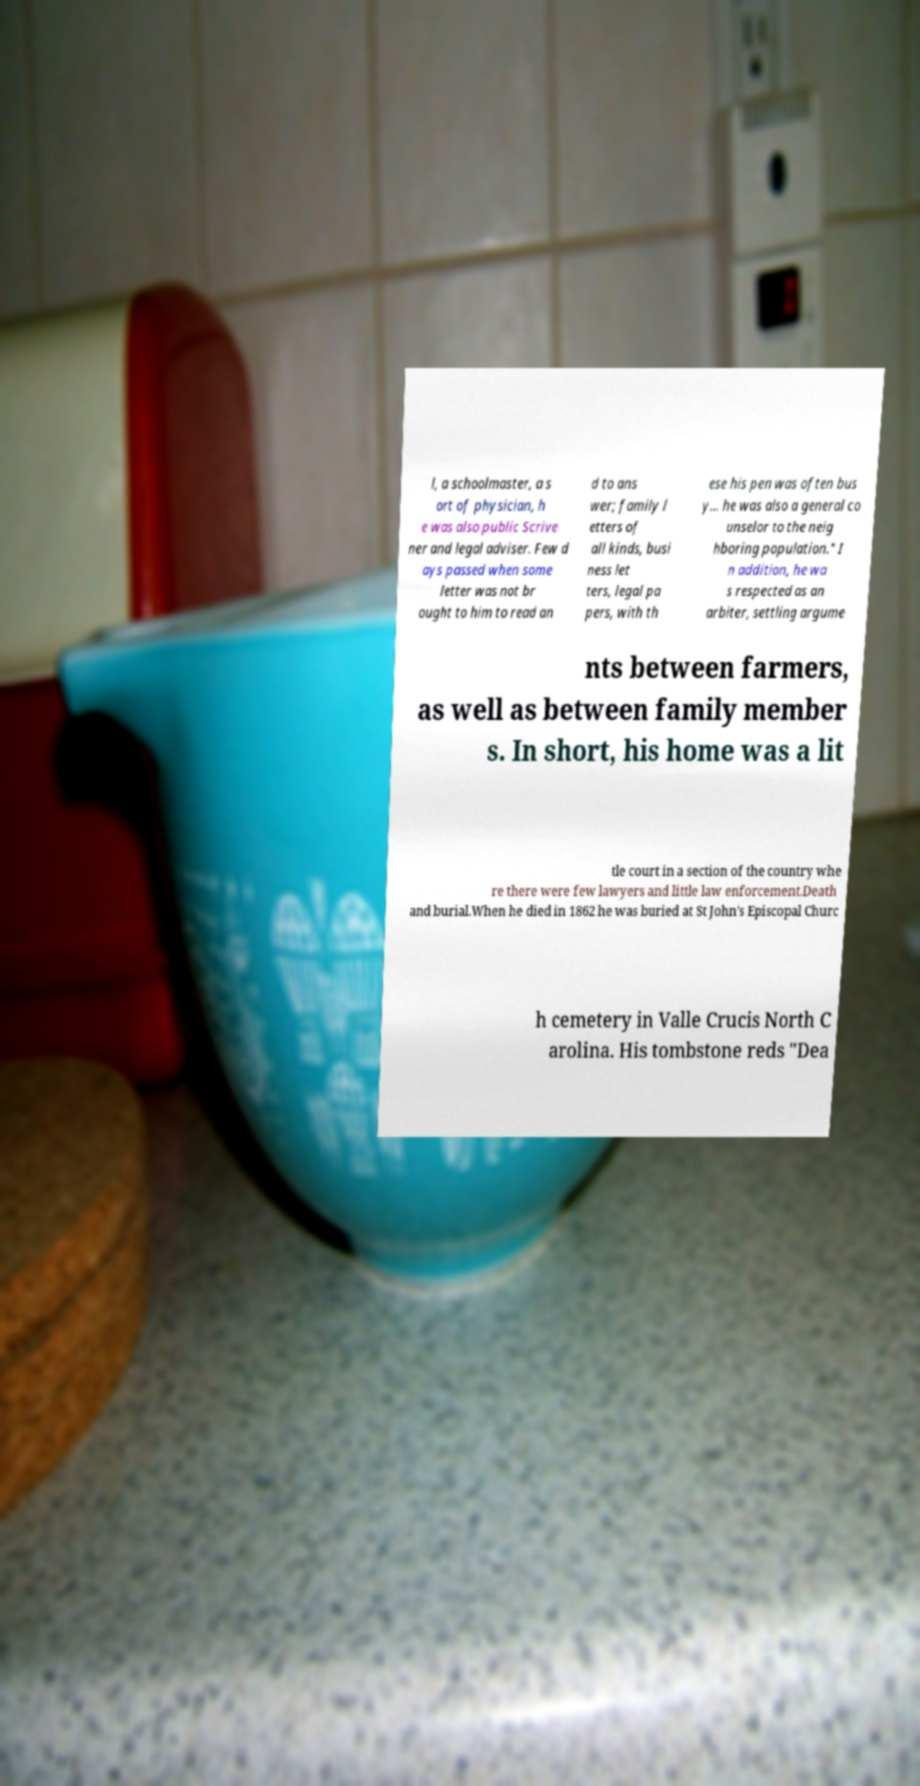For documentation purposes, I need the text within this image transcribed. Could you provide that? l, a schoolmaster, a s ort of physician, h e was also public Scrive ner and legal adviser. Few d ays passed when some letter was not br ought to him to read an d to ans wer; family l etters of all kinds, busi ness let ters, legal pa pers, with th ese his pen was often bus y... he was also a general co unselor to the neig hboring population." I n addition, he wa s respected as an arbiter, settling argume nts between farmers, as well as between family member s. In short, his home was a lit tle court in a section of the country whe re there were few lawyers and little law enforcement.Death and burial.When he died in 1862 he was buried at St John's Episcopal Churc h cemetery in Valle Crucis North C arolina. His tombstone reds "Dea 